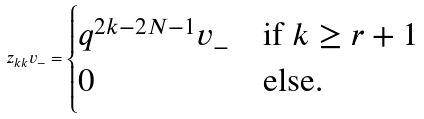Convert formula to latex. <formula><loc_0><loc_0><loc_500><loc_500>z _ { k k } v _ { - } = \begin{cases} q ^ { 2 k - 2 N - 1 } v _ { - } & \text {if $k\geq r+1$} \\ 0 & \text {else.} \end{cases}</formula> 